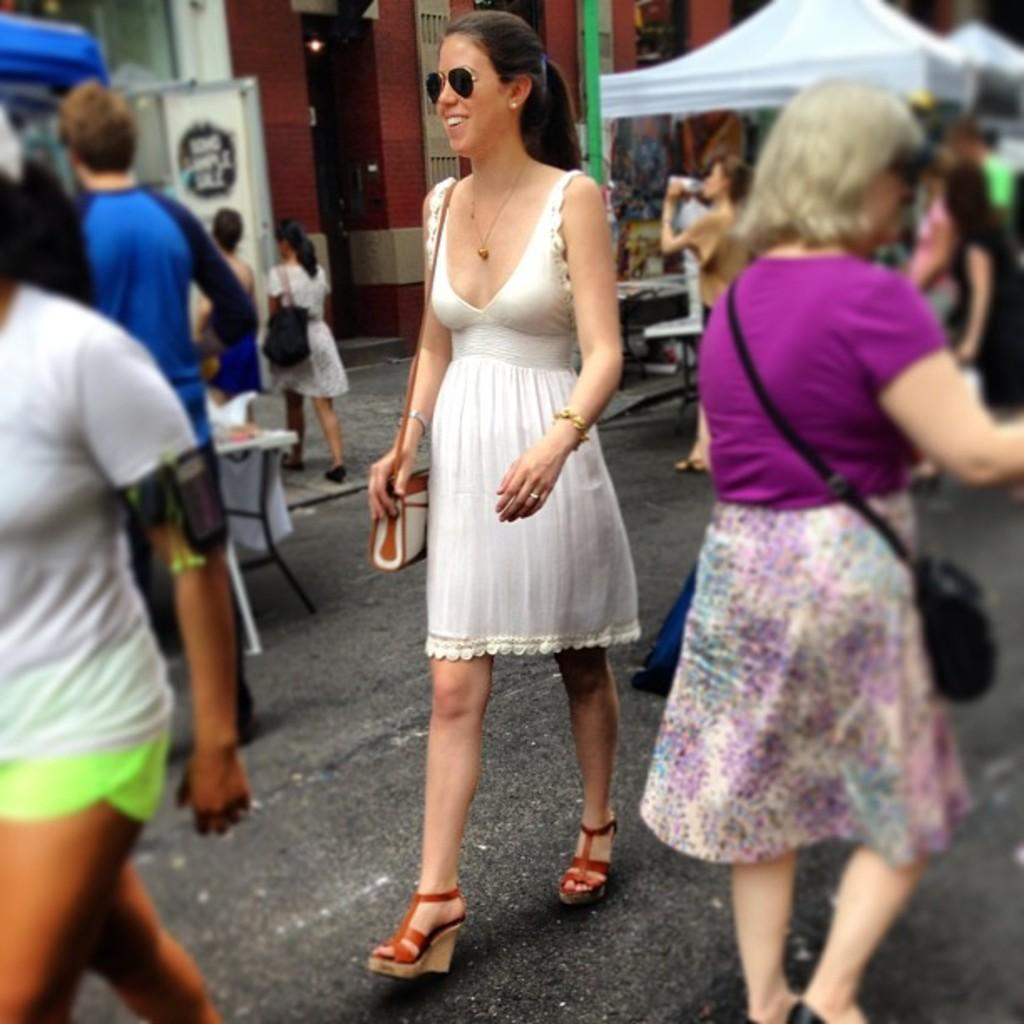Who can be seen in the image? There are people in the image. What are some of the women in the image doing? Some women in the image are carrying bags. What can be seen in the background of the image? There are stalls and other objects on the ground in the background of the image. What is the name of the theory that the maid in the image is discussing with the summer sun? There is no maid or mention of a theory or summer sun in the image; it only features people and stalls in the background. 